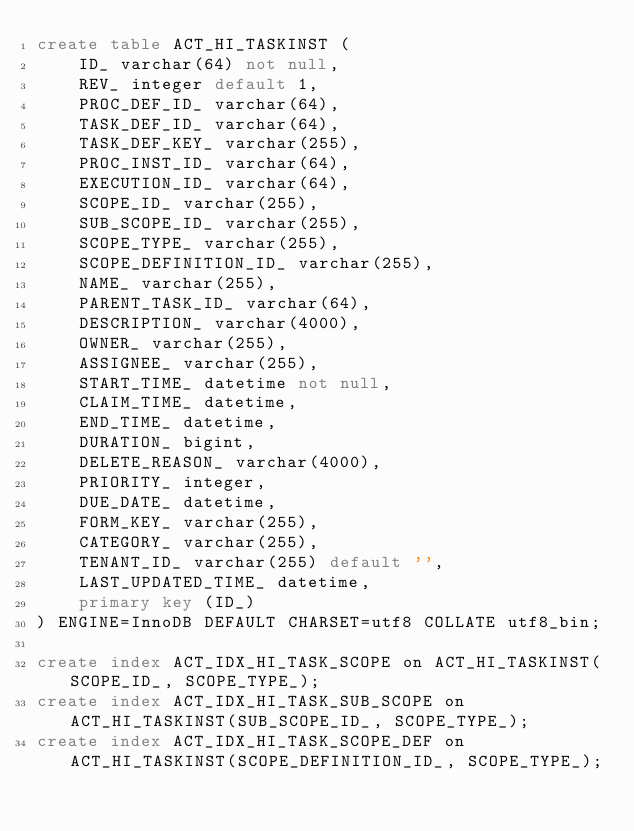Convert code to text. <code><loc_0><loc_0><loc_500><loc_500><_SQL_>create table ACT_HI_TASKINST (
    ID_ varchar(64) not null,
    REV_ integer default 1,
    PROC_DEF_ID_ varchar(64),
    TASK_DEF_ID_ varchar(64),
    TASK_DEF_KEY_ varchar(255),
    PROC_INST_ID_ varchar(64),
    EXECUTION_ID_ varchar(64),
    SCOPE_ID_ varchar(255),
    SUB_SCOPE_ID_ varchar(255),
    SCOPE_TYPE_ varchar(255),
    SCOPE_DEFINITION_ID_ varchar(255),
    NAME_ varchar(255),
    PARENT_TASK_ID_ varchar(64),
    DESCRIPTION_ varchar(4000),
    OWNER_ varchar(255),
    ASSIGNEE_ varchar(255),
    START_TIME_ datetime not null,
    CLAIM_TIME_ datetime,
    END_TIME_ datetime,
    DURATION_ bigint,
    DELETE_REASON_ varchar(4000),
    PRIORITY_ integer,
    DUE_DATE_ datetime,
    FORM_KEY_ varchar(255),
    CATEGORY_ varchar(255),
    TENANT_ID_ varchar(255) default '',
    LAST_UPDATED_TIME_ datetime,
    primary key (ID_)
) ENGINE=InnoDB DEFAULT CHARSET=utf8 COLLATE utf8_bin;

create index ACT_IDX_HI_TASK_SCOPE on ACT_HI_TASKINST(SCOPE_ID_, SCOPE_TYPE_);
create index ACT_IDX_HI_TASK_SUB_SCOPE on ACT_HI_TASKINST(SUB_SCOPE_ID_, SCOPE_TYPE_);
create index ACT_IDX_HI_TASK_SCOPE_DEF on ACT_HI_TASKINST(SCOPE_DEFINITION_ID_, SCOPE_TYPE_);
</code> 